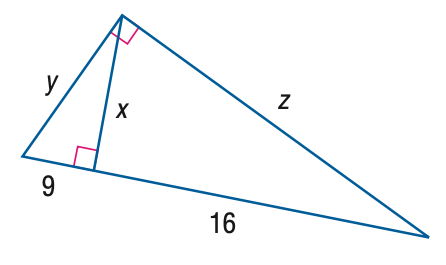Question: Find y.
Choices:
A. 15
B. 16
C. 18
D. 20
Answer with the letter. Answer: A 